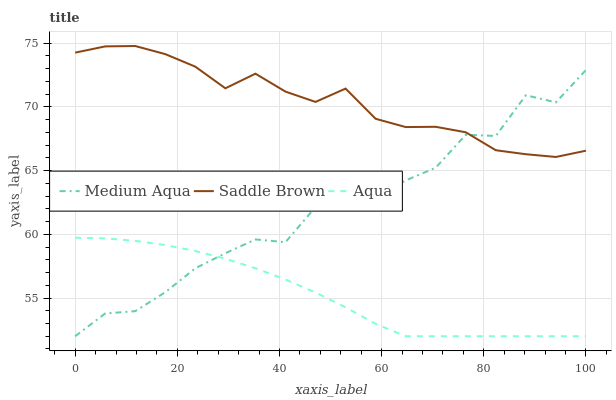Does Aqua have the minimum area under the curve?
Answer yes or no. Yes. Does Saddle Brown have the maximum area under the curve?
Answer yes or no. Yes. Does Medium Aqua have the minimum area under the curve?
Answer yes or no. No. Does Medium Aqua have the maximum area under the curve?
Answer yes or no. No. Is Aqua the smoothest?
Answer yes or no. Yes. Is Medium Aqua the roughest?
Answer yes or no. Yes. Is Saddle Brown the smoothest?
Answer yes or no. No. Is Saddle Brown the roughest?
Answer yes or no. No. Does Aqua have the lowest value?
Answer yes or no. Yes. Does Saddle Brown have the lowest value?
Answer yes or no. No. Does Saddle Brown have the highest value?
Answer yes or no. Yes. Does Medium Aqua have the highest value?
Answer yes or no. No. Is Aqua less than Saddle Brown?
Answer yes or no. Yes. Is Saddle Brown greater than Aqua?
Answer yes or no. Yes. Does Medium Aqua intersect Aqua?
Answer yes or no. Yes. Is Medium Aqua less than Aqua?
Answer yes or no. No. Is Medium Aqua greater than Aqua?
Answer yes or no. No. Does Aqua intersect Saddle Brown?
Answer yes or no. No. 